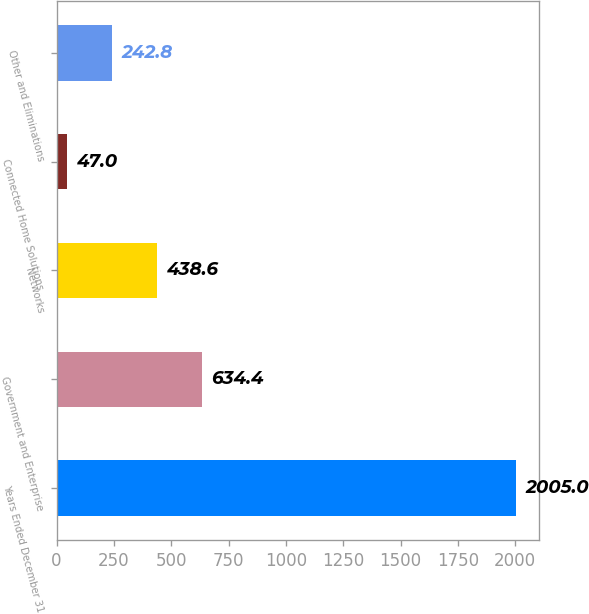<chart> <loc_0><loc_0><loc_500><loc_500><bar_chart><fcel>Years Ended December 31<fcel>Government and Enterprise<fcel>Networks<fcel>Connected Home Solutions<fcel>Other and Eliminations<nl><fcel>2005<fcel>634.4<fcel>438.6<fcel>47<fcel>242.8<nl></chart> 